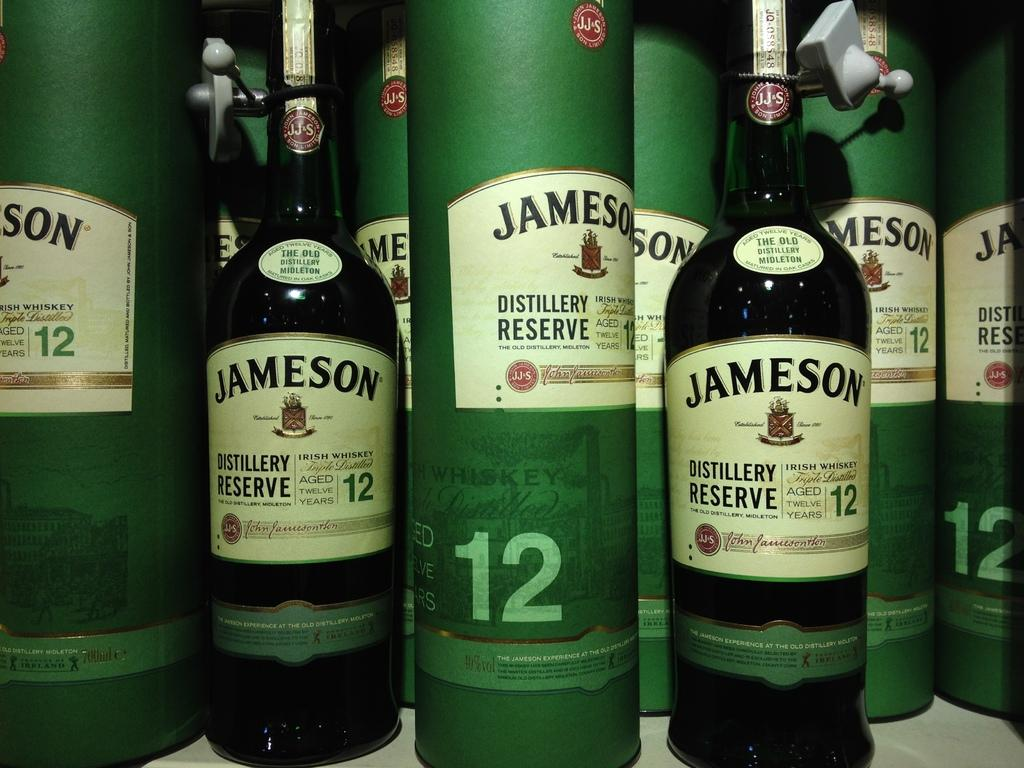<image>
Share a concise interpretation of the image provided. Several bottles of Jameson Distillery Reserve that has been aged for 12 years. 